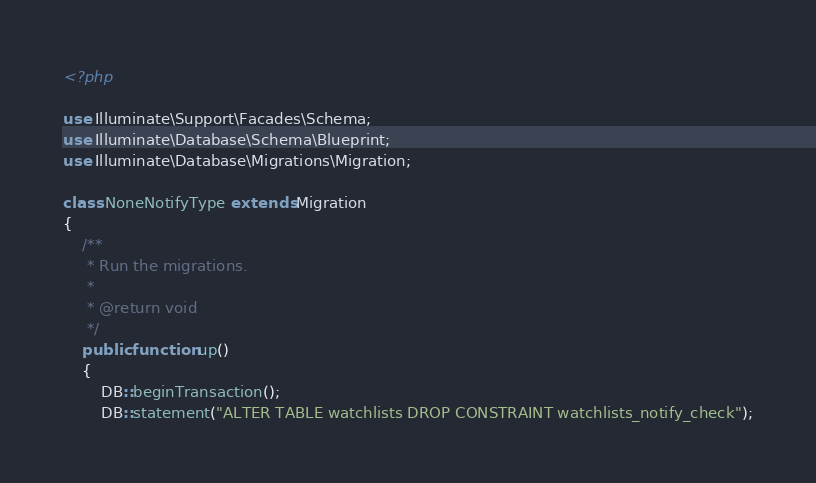<code> <loc_0><loc_0><loc_500><loc_500><_PHP_><?php

use Illuminate\Support\Facades\Schema;
use Illuminate\Database\Schema\Blueprint;
use Illuminate\Database\Migrations\Migration;

class NoneNotifyType extends Migration
{
    /**
     * Run the migrations.
     *
     * @return void
     */
    public function up()
    {
        DB::beginTransaction();
        DB::statement("ALTER TABLE watchlists DROP CONSTRAINT watchlists_notify_check");</code> 